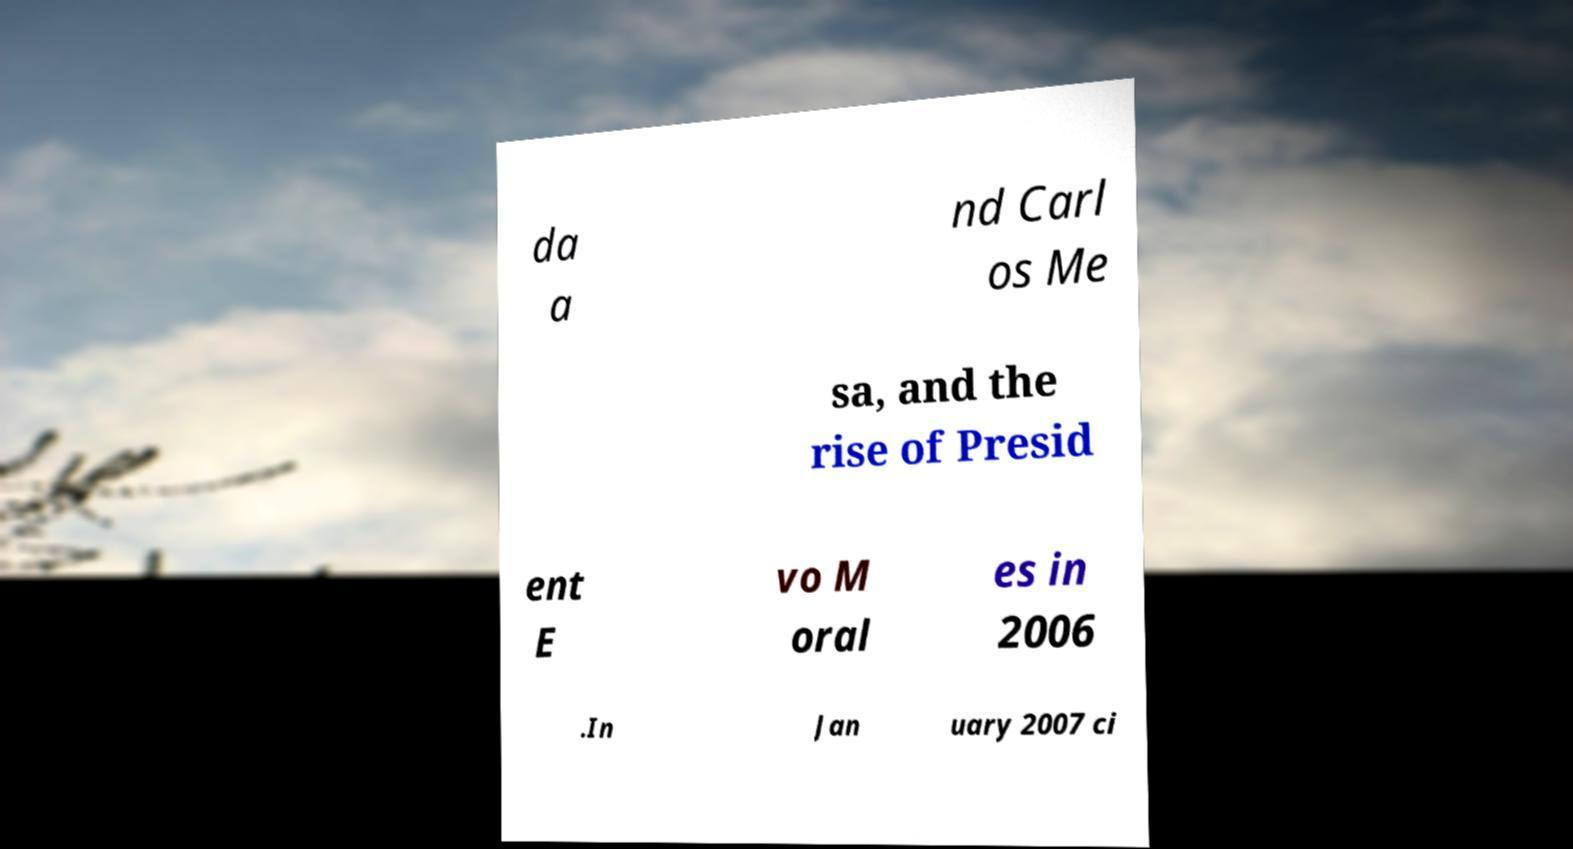Could you extract and type out the text from this image? da a nd Carl os Me sa, and the rise of Presid ent E vo M oral es in 2006 .In Jan uary 2007 ci 